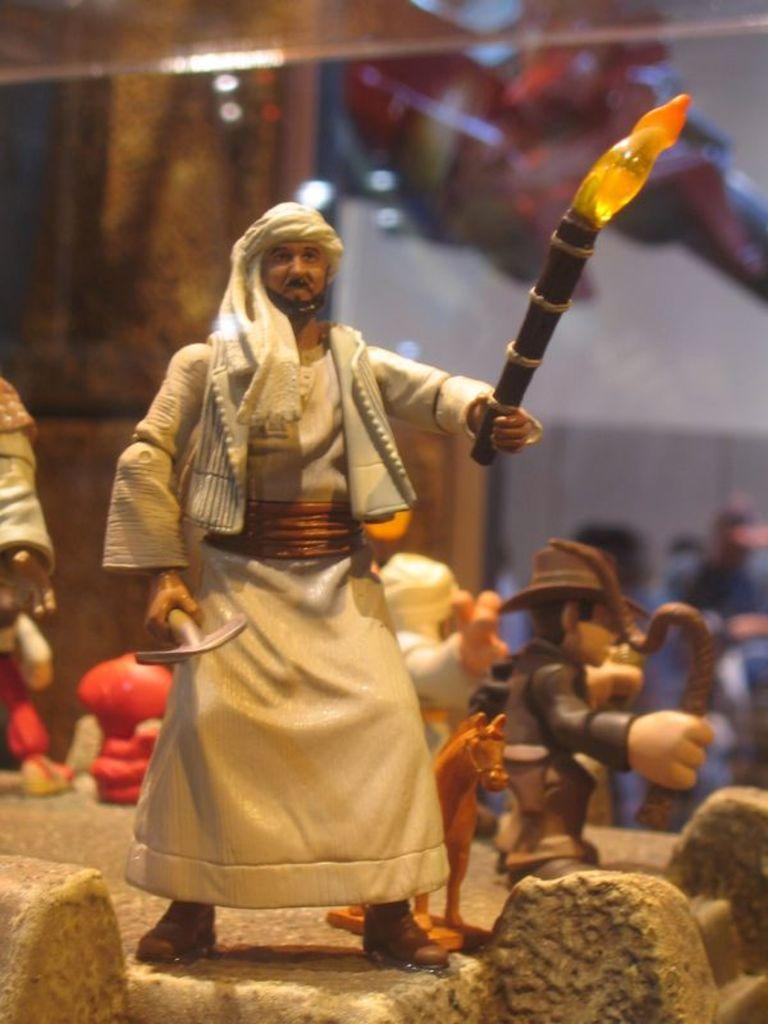What can be seen in the image besides the man? There are toys and an object that resembles a horse in the image. What is the man holding in his hands? The man is holding a tool and a stick with fire in his hands. How would you describe the man's actions in the image? The man appears to be working or performing some activity with the tool and fire. What can be said about the background of the image? The background of the image appears blurry. How many houses can be seen in the image? There are no houses visible in the image. How many kittens are playing with the toys in the image? There are no kittens present in the image. 